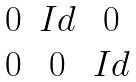Convert formula to latex. <formula><loc_0><loc_0><loc_500><loc_500>\begin{matrix} 0 & I d & 0 \\ 0 & 0 & I d \end{matrix}</formula> 